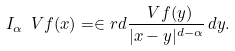<formula> <loc_0><loc_0><loc_500><loc_500>I _ { \alpha } \ V { f } ( x ) = \in r d \frac { \ V { f } ( y ) } { | x - y | ^ { d - \alpha } } \, d y .</formula> 